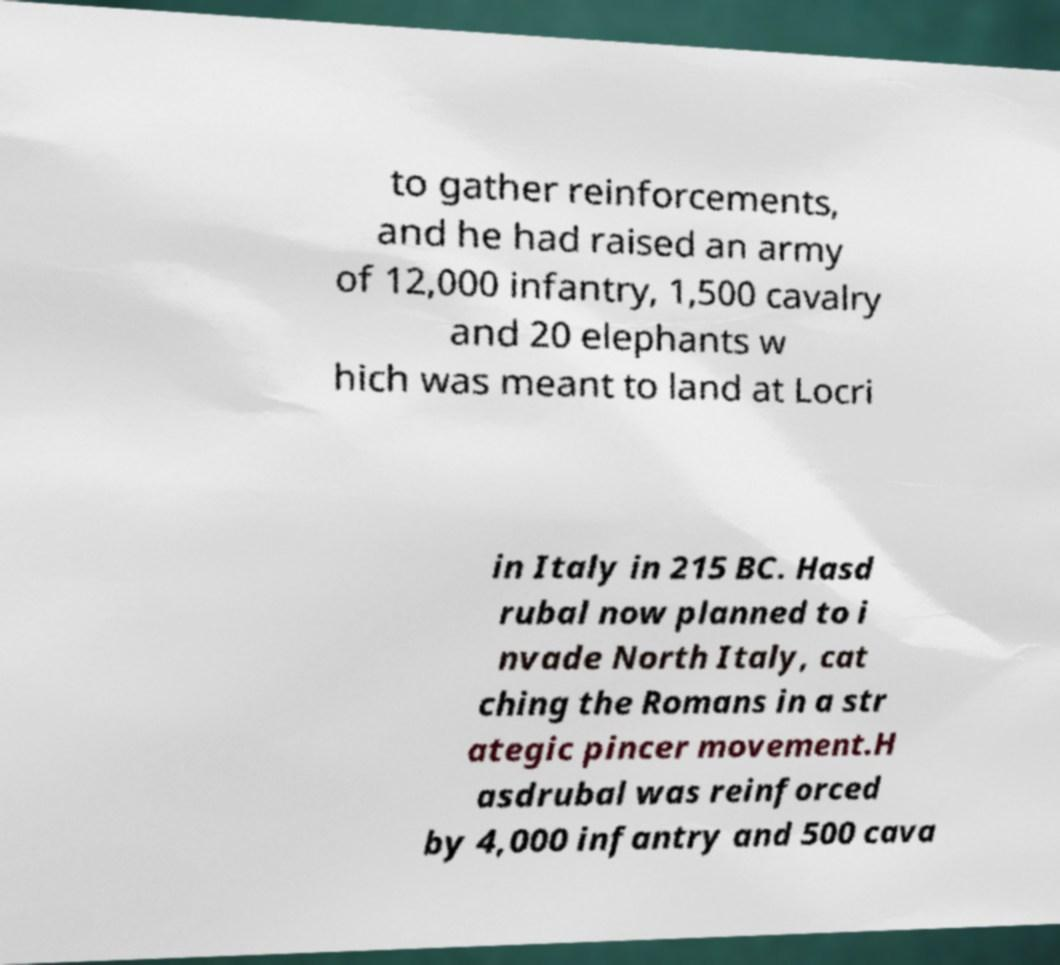Please identify and transcribe the text found in this image. to gather reinforcements, and he had raised an army of 12,000 infantry, 1,500 cavalry and 20 elephants w hich was meant to land at Locri in Italy in 215 BC. Hasd rubal now planned to i nvade North Italy, cat ching the Romans in a str ategic pincer movement.H asdrubal was reinforced by 4,000 infantry and 500 cava 